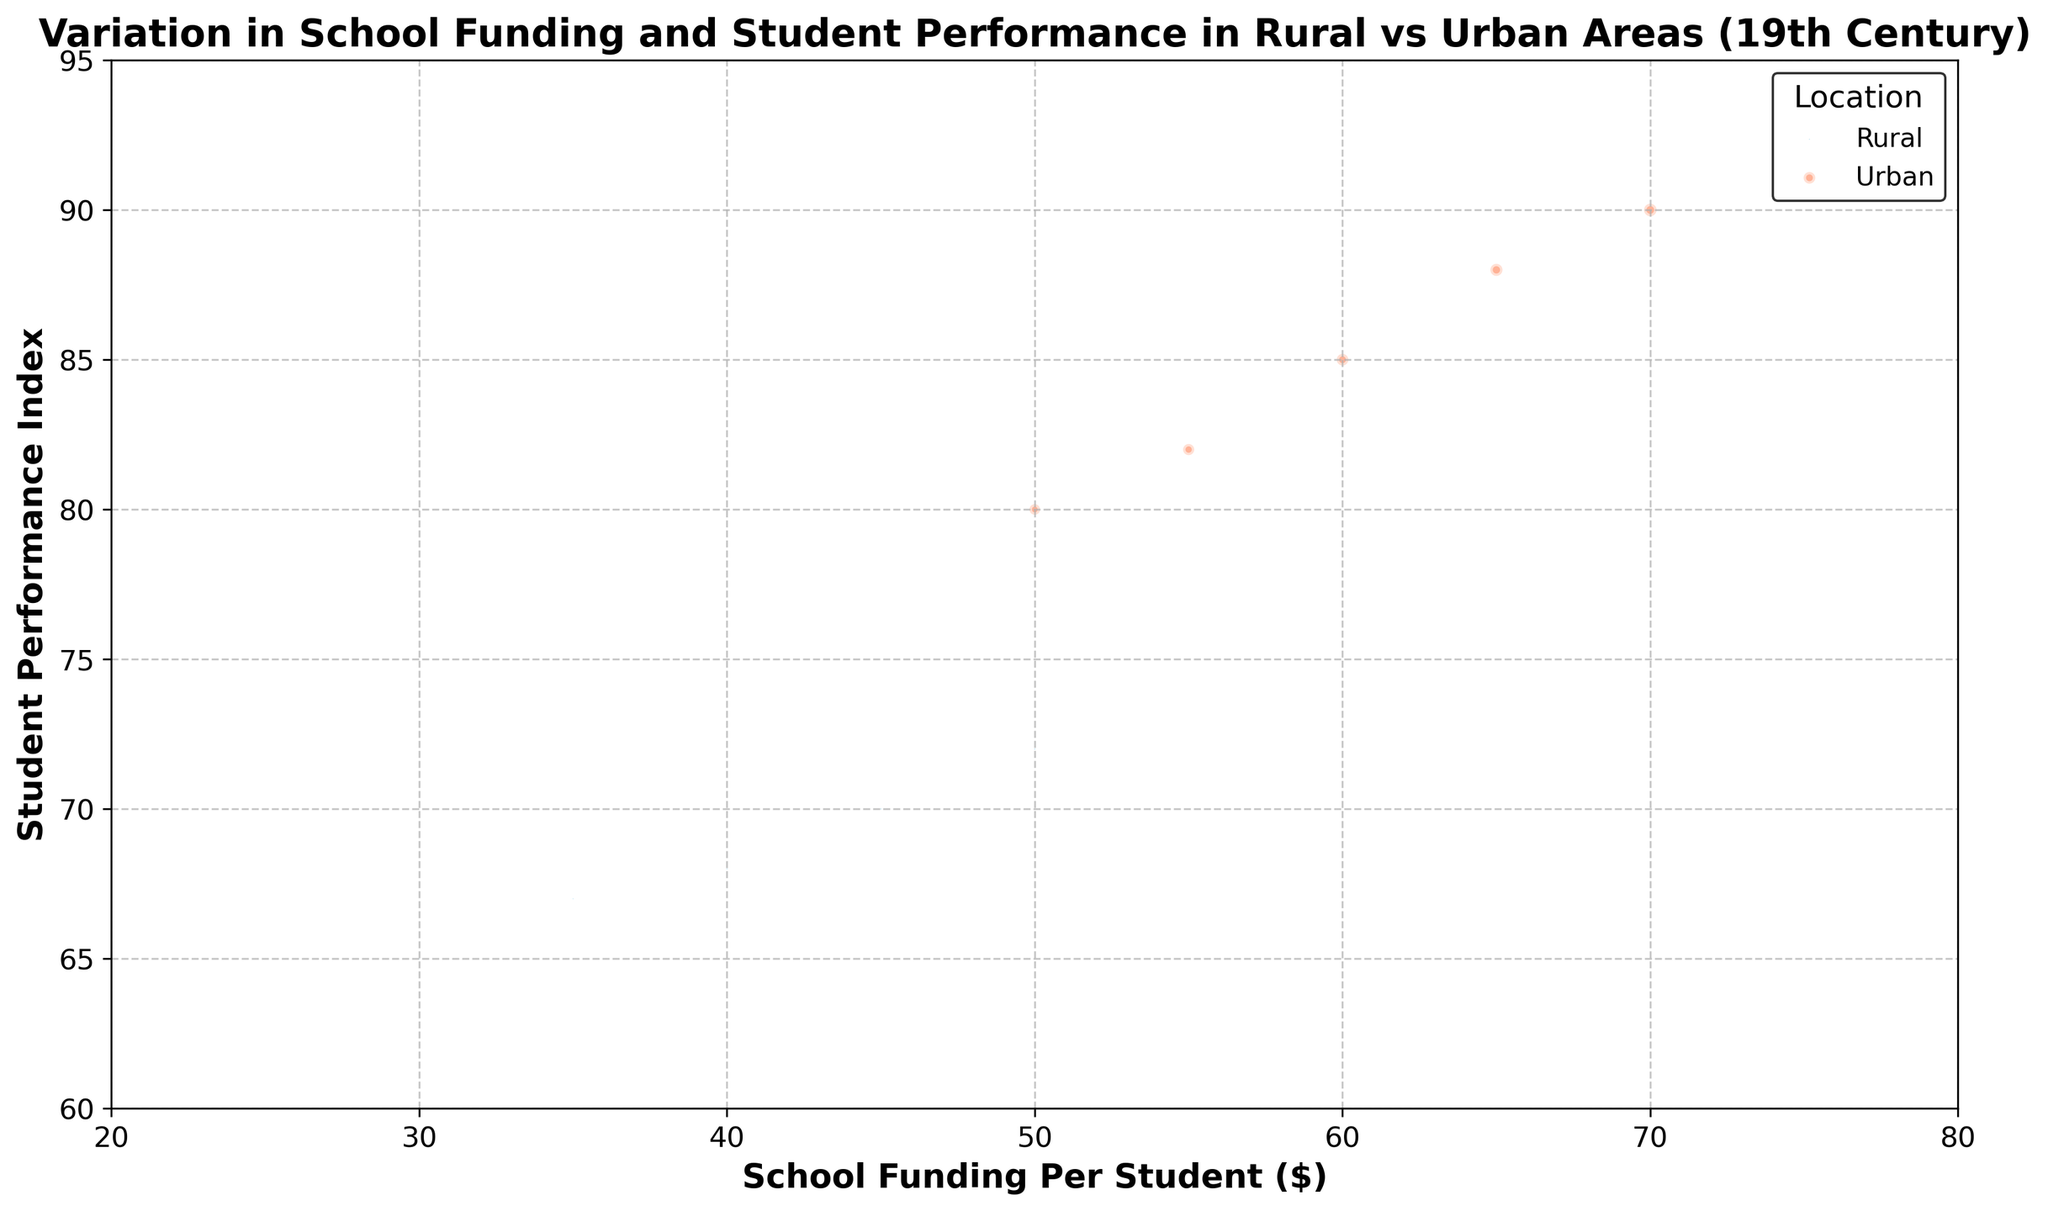What is the general trend in the relationship between school funding per student and student performance index in rural areas from 1850 to 1930? The plot shows that as school funding per student increases in rural areas, the student performance index also increases. For example, in 1850, rural areas had $30 per student with a performance index of 65. By 1930, funding increased to $50, and the performance index rose to 72. This suggests a positive correlation.
Answer: Positive correlation How does the population density affect the visual representation of rural and urban areas in the plot? In the plot, bubble size represents population density. Urban area bubbles are significantly larger due to higher population densities (e.g., 2000 in 1850 and 2800 in 1930) compared to rural areas, which have much smaller bubbles (e.g., 10 in 1850 and 20 in 1930).
Answer: Urban bubbles are larger Which year shows the highest student performance index for urban areas, and what is the corresponding school funding per student for that year? The highest student performance index in urban areas is 90, observed in the year 1930. The corresponding school funding per student for that year is $70.
Answer: 1930, $70 By how much did the student performance index in urban areas increase from 1850 to 1930? The student performance index in urban areas increased from 80 in 1850 to 90 in 1930. To find the difference, subtract 80 from 90, resulting in an increase of 10 points.
Answer: 10 points Which location—rural or urban—has a greater increase in school funding per student from 1850 to 1930, and what is the amount? In rural areas, school funding per student increased from $30 in 1850 to $50 in 1930, a difference of $20. In urban areas, it increased from $50 in 1850 to $70 in 1930, a difference of $20. Both locations have the same increase in funding per student.
Answer: Both, $20 How does the student performance index for rural areas in 1870 compare to that in urban areas in the same year? In 1870, the student performance index is 67 in rural areas and 82 in urban areas. By subtracting 67 from 82, we see that urban areas have a performance index that is 15 points higher than rural areas.
Answer: Urban areas have 15 points higher Comparing the bubble sizes, which year had the least population density in rural areas and what impact does it have on the student performance index? The smallest bubble size for rural areas is in 1850, representing a population density of 10. During this year, the student performance index is 65, which is the lowest across all the years shown for rural areas.
Answer: 1850, lowest performance index What is the average school funding per student in urban areas across the years shown in the plot? The school funding per student in urban areas for the years 1850, 1870, 1890, 1910, and 1930 are $50, $55, $60, $65, and $70, respectively. Summing these gives 50 + 55 + 60 + 65 + 70 = 300. Dividing by the 5 data points, the average is 300 / 5 = $60.
Answer: $60 Which location shows a more significant increase in the student performance index from 1850 to 1890, and by how much? In rural areas, the student performance index increased from 65 in 1850 to 68 in 1890, a difference of 3 points. In urban areas, it increased from 80 in 1850 to 85 in 1890, a difference of 5 points. Urban areas show a more significant increase by 2 points.
Answer: Urban, 2 points Does the data indicate any year in which rural areas had a higher student performance index than urban areas? The plot and data provided indicate that for all the years (1850, 1870, 1890, 1910, 1930), urban areas consistently have a higher student performance index compared to rural areas.
Answer: No 